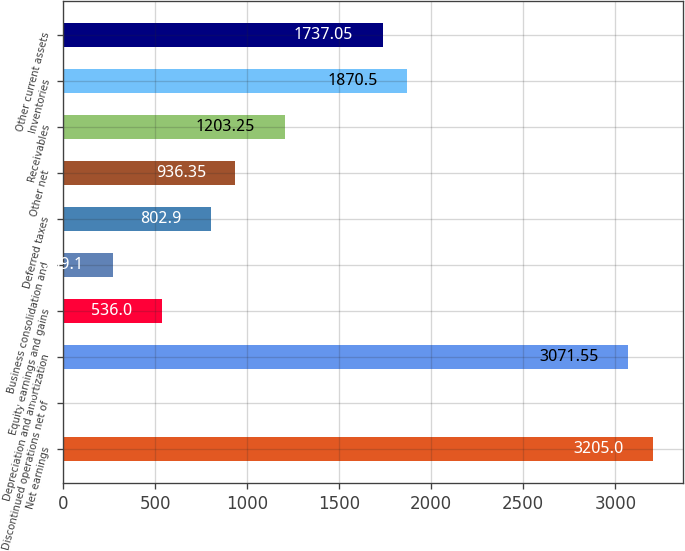<chart> <loc_0><loc_0><loc_500><loc_500><bar_chart><fcel>Net earnings<fcel>Discontinued operations net of<fcel>Depreciation and amortization<fcel>Equity earnings and gains<fcel>Business consolidation and<fcel>Deferred taxes<fcel>Other net<fcel>Receivables<fcel>Inventories<fcel>Other current assets<nl><fcel>3205<fcel>2.2<fcel>3071.55<fcel>536<fcel>269.1<fcel>802.9<fcel>936.35<fcel>1203.25<fcel>1870.5<fcel>1737.05<nl></chart> 